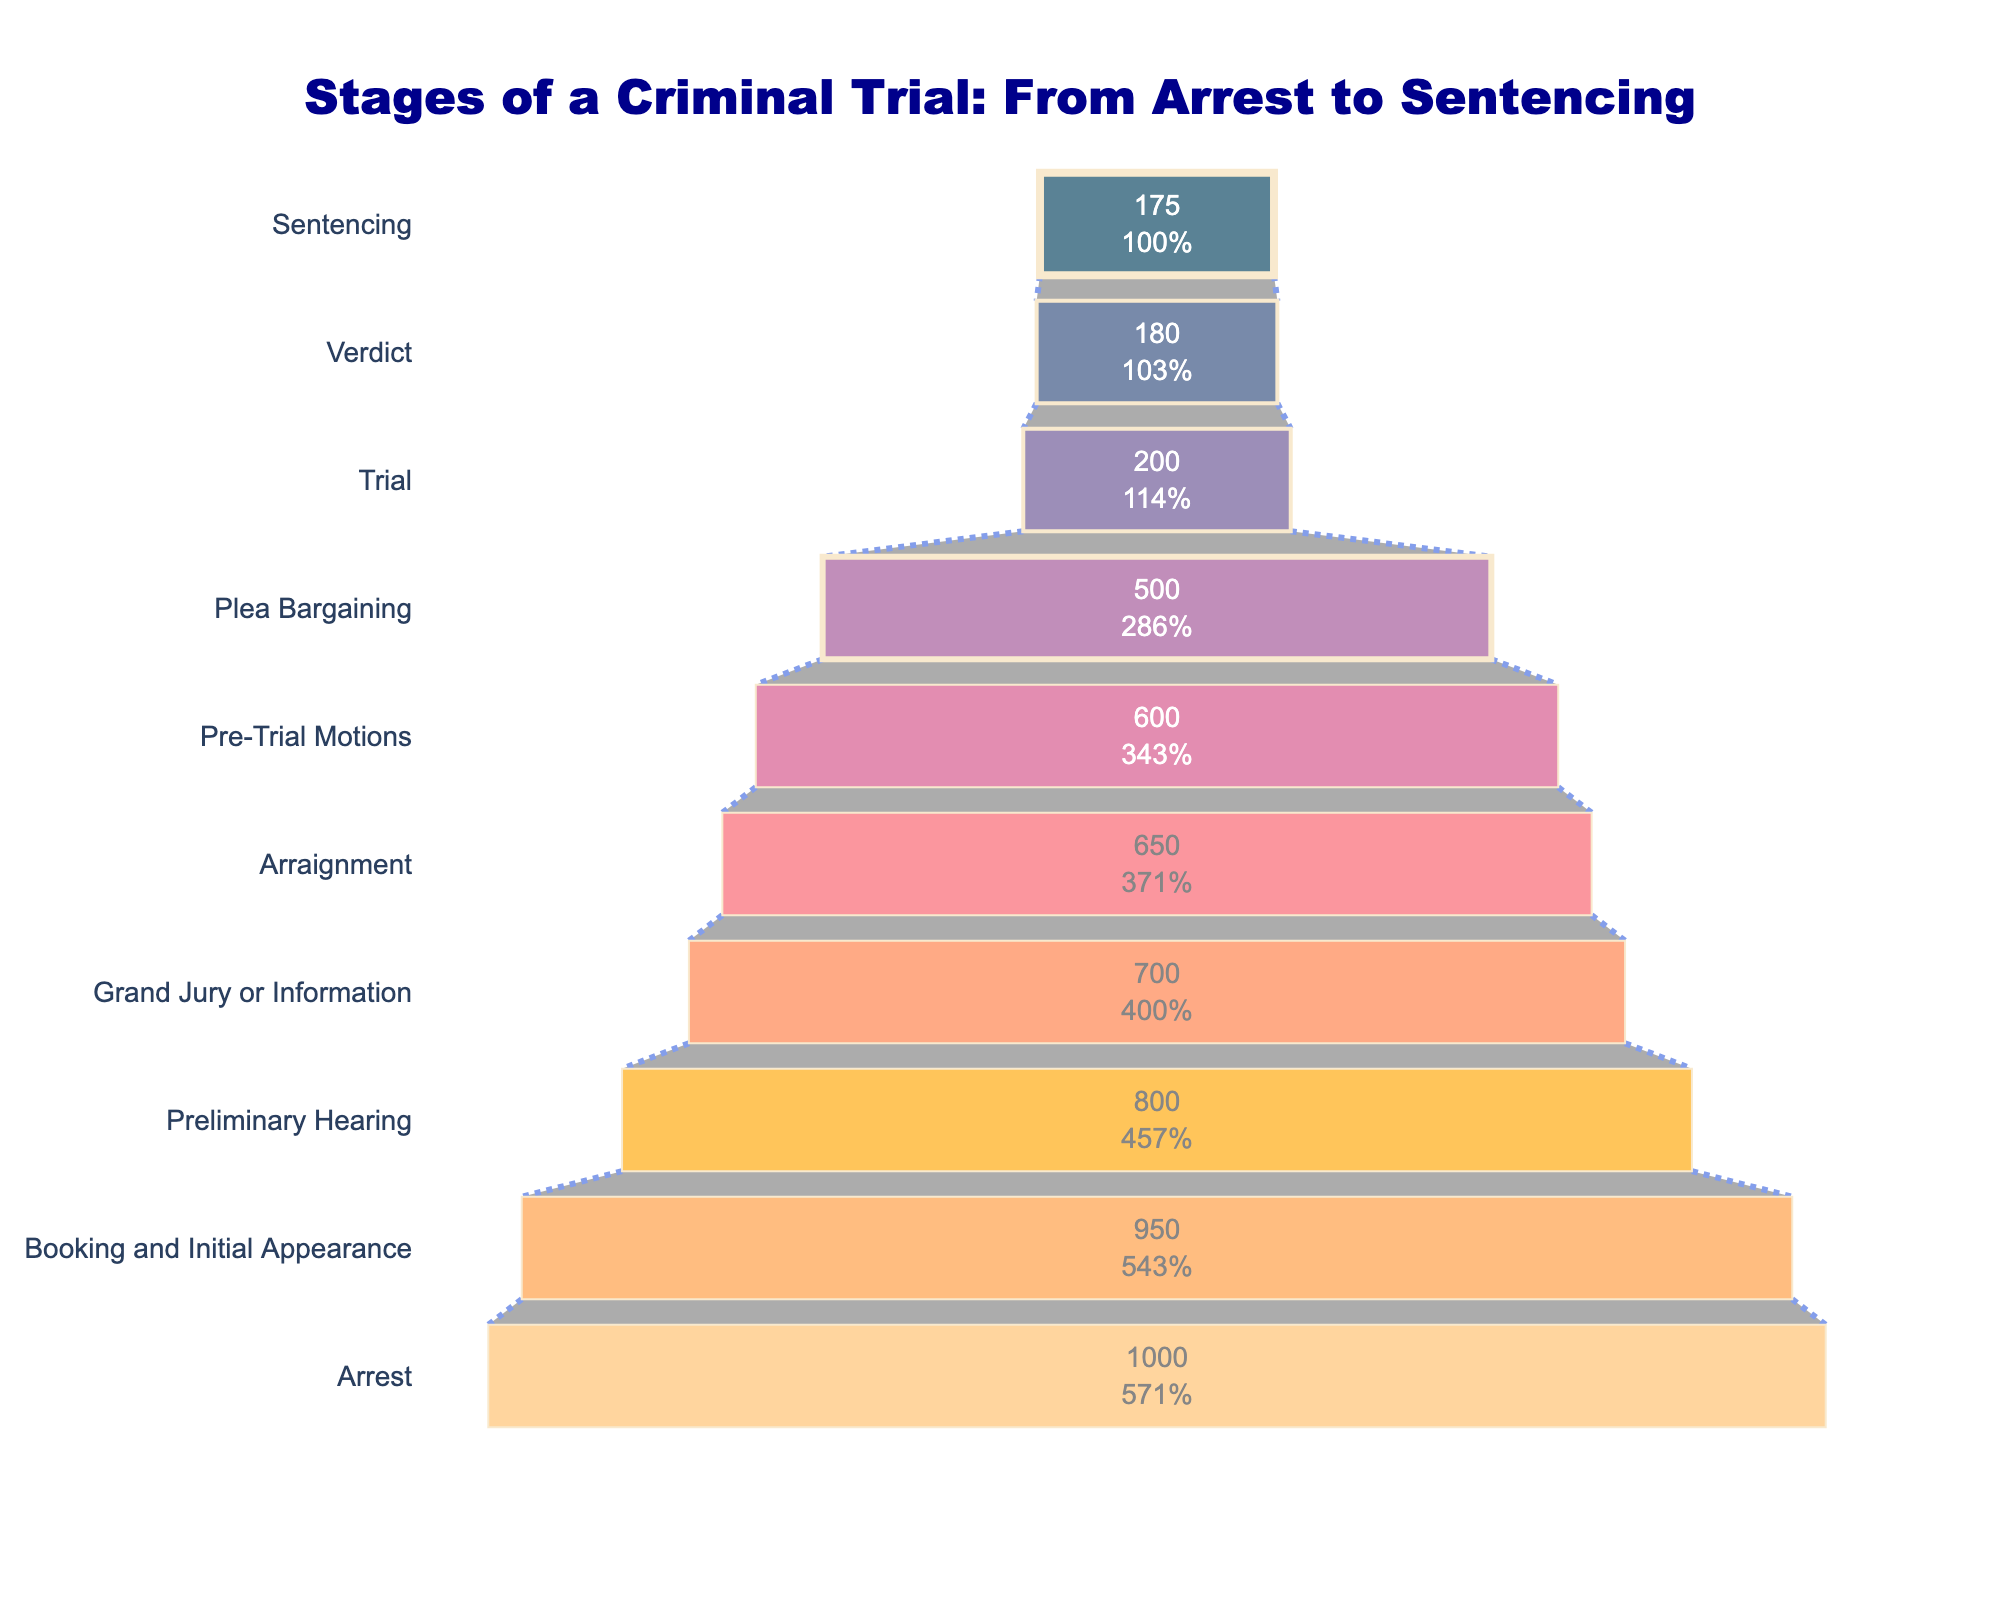What's the title of the Funnel Chart? The title is located at the top of the figure and it reads: "Stages of a Criminal Trial: From Arrest to Sentencing."
Answer: Stages of a Criminal Trial: From Arrest to Sentencing How many stages are depicted in the Funnel Chart? By counting the labels on the y-axis, which represent the different stages of a criminal trial, we see there are 10 stages.
Answer: 10 Which stage has the highest number of cases? By looking at the largest section at the top of the funnel, which corresponds to the Arrest stage, we see it has the highest number of cases at 1000.
Answer: Arrest What percentage of cases reach the sentencing stage compared to the arrest stage? The initial number of cases at the Arrest stage is 1000. At the Sentencing stage, it's 175. The percentage is calculated as (175/1000)*100 = 17.5%.
Answer: 17.5% How many cases are lost between the preliminary hearing and the grand jury stage? The number of cases at the preliminary hearing stage is 800, and at the grand jury stage, it's 700. The difference is 800 - 700 = 100.
Answer: 100 Which stage shows the greatest reduction in the number of cases from the previous stage? By comparing the reduction at each stage, the largest drop is between Plea Bargaining (500 cases) and Trial (200 cases), a drop of 500 - 200 = 300 cases.
Answer: Plea Bargaining to Trial What is the total number of cases that do not reach the trial stage? The initial number of cases is 1000, and the number reaching the trial stage is 200. Therefore, the number not reaching trial is 1000 - 200 = 800.
Answer: 800 What color is used to represent the preliminary hearing stage? The preliminary hearing stage in the funnel is represented by the 8th color from the bottom, which is a shade of purple.
Answer: Purple What is the difference in the number of cases between the arraignment stage and the pre-trial motions stage? According to the chart, there are 650 cases at the arraignment stage and 600 at the pre-trial motions stage. The difference is 650 - 600 = 50 cases.
Answer: 50 What is the median number of cases across all stages? Listing the number of cases from highest to lowest: 1000, 950, 800, 700, 650, 600, 500, 200, 180, 175. The median is the average of the 5th and 6th values: (650 + 600) / 2 = 625.
Answer: 625 